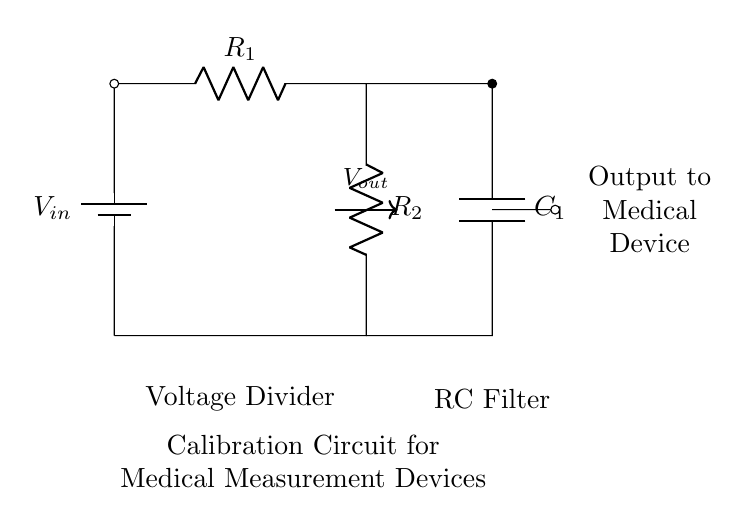What is the input voltage in this circuit? The circuit shows a battery labeled with the symbol for voltage, indicating that the input voltage is a defined reference point, typically represented as V_in.
Answer: V_in What are the resistance values used in the voltage divider? The circuit diagram contains two resistors labeled R_1 and R_2. These denote the resistance values in the voltage divider. However, specific numerical values are not given in the diagram.
Answer: R_1, R_2 What is the function of the capacitor in this circuit? The capacitor, labeled C_1, acts as a filter component in the circuit. Its primary role is to smooth out voltage fluctuations at the output, allowing stable voltage levels to be maintained for measurements.
Answer: Filtering What is the output of the voltage divider? The output, labeled V_out, is taken from the node between R_1 and R_2, indicating that this is the voltage across R_2. This voltage is crucial for operation in medical measurement devices.
Answer: V_out Explain the significance of the calibration circuit. The circuit is described as a calibration circuit for medical measurement devices. This implies that the arrangement and values of the components are specifically chosen to ensure accurate readings and performance of such devices, which is critical in medical applications.
Answer: Accuracy What type of filtering does the capacitor provide? The capacitor is part of the RC filter, which primarily provides low-pass filtering. This means it allows low-frequency signals to pass while attenuating higher-frequency noise, ensuring cleaner signals for the medical devices.
Answer: Low-pass 